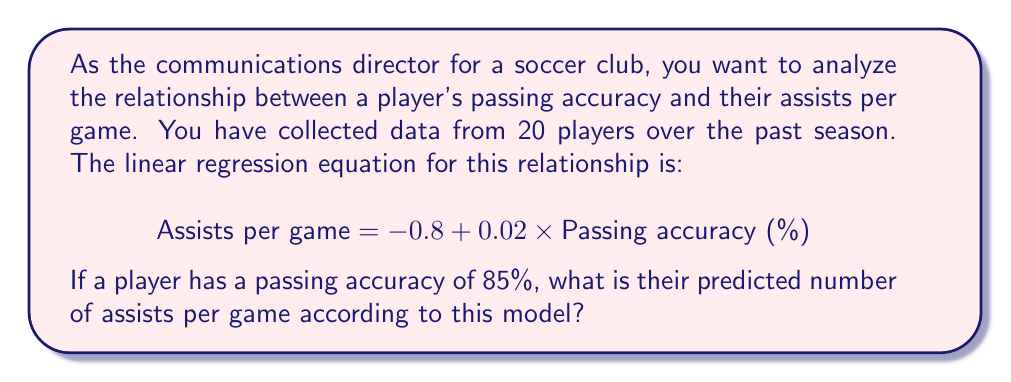Can you solve this math problem? To solve this problem, we'll use the given linear regression equation and substitute the player's passing accuracy:

1. The linear regression equation is:
   $$ \text{Assists per game} = -0.8 + 0.02 \times \text{Passing accuracy (%)} $$

2. We're given that the player's passing accuracy is 85%. Let's substitute this value into the equation:
   $$ \text{Assists per game} = -0.8 + 0.02 \times 85 $$

3. Now, let's solve the equation step by step:
   $$ \text{Assists per game} = -0.8 + 1.7 $$
   $$ \text{Assists per game} = 0.9 $$

4. Interpretation: According to this regression model, a player with a passing accuracy of 85% is predicted to have 0.9 assists per game.

Note: This model assumes a linear relationship between passing accuracy and assists per game. In reality, the relationship might be more complex, and other factors could influence a player's assist rate.
Answer: 0.9 assists per game 